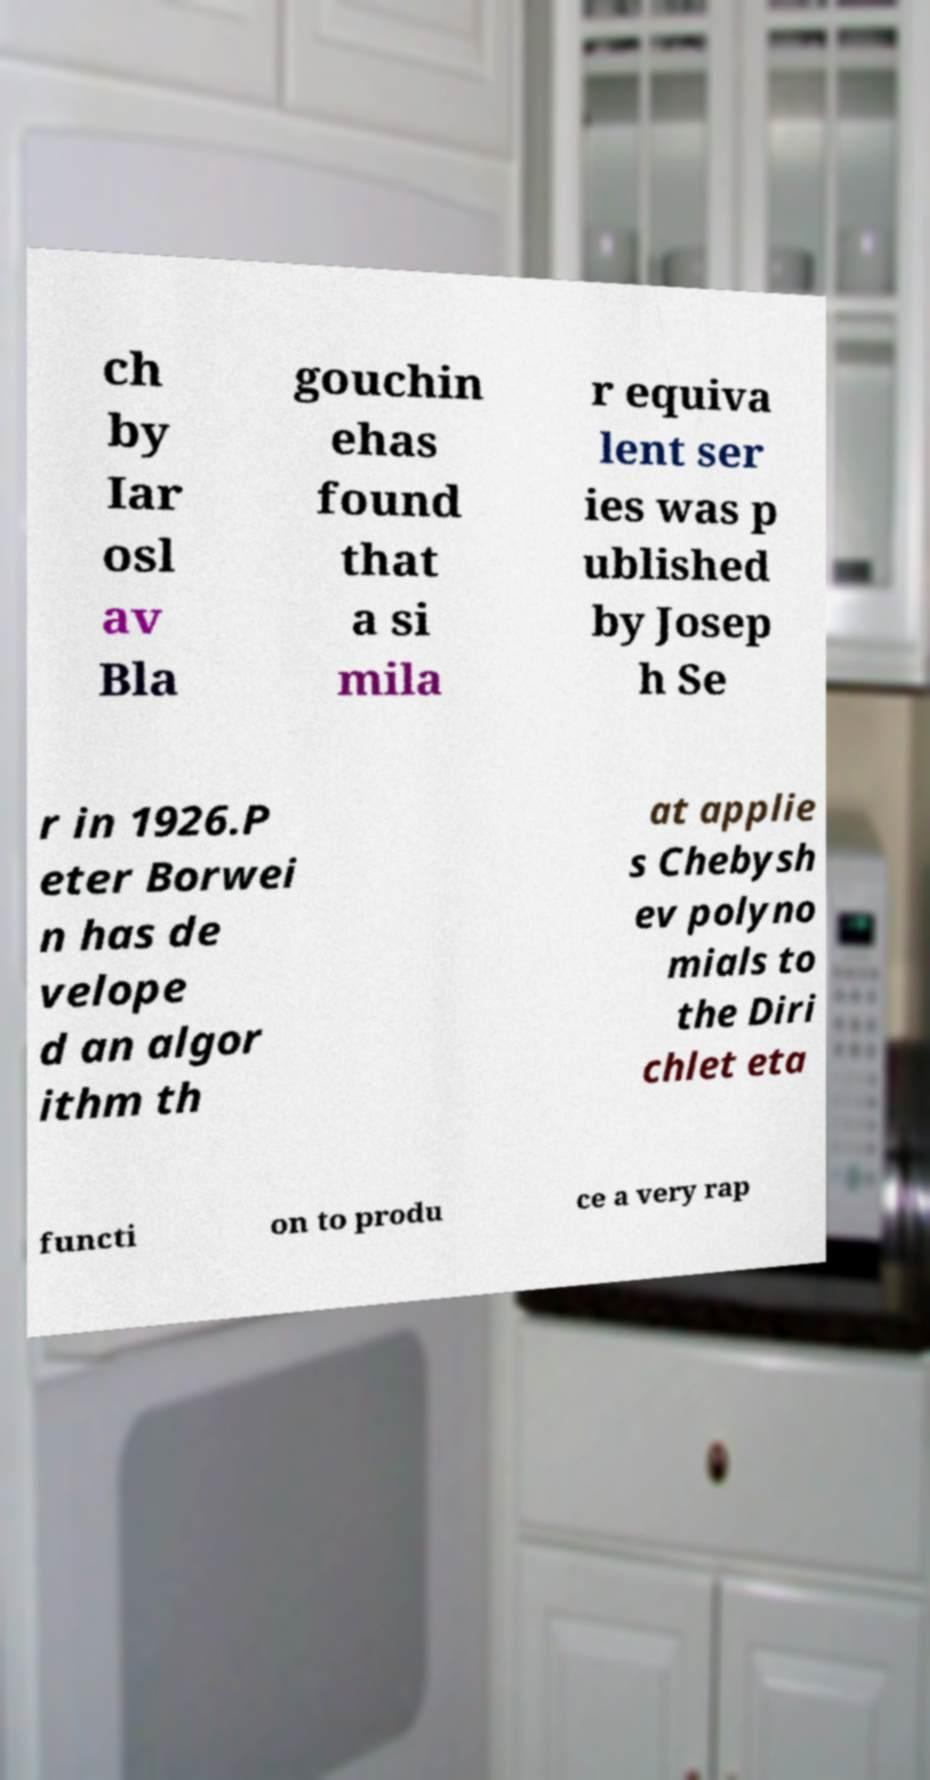What messages or text are displayed in this image? I need them in a readable, typed format. ch by Iar osl av Bla gouchin ehas found that a si mila r equiva lent ser ies was p ublished by Josep h Se r in 1926.P eter Borwei n has de velope d an algor ithm th at applie s Chebysh ev polyno mials to the Diri chlet eta functi on to produ ce a very rap 